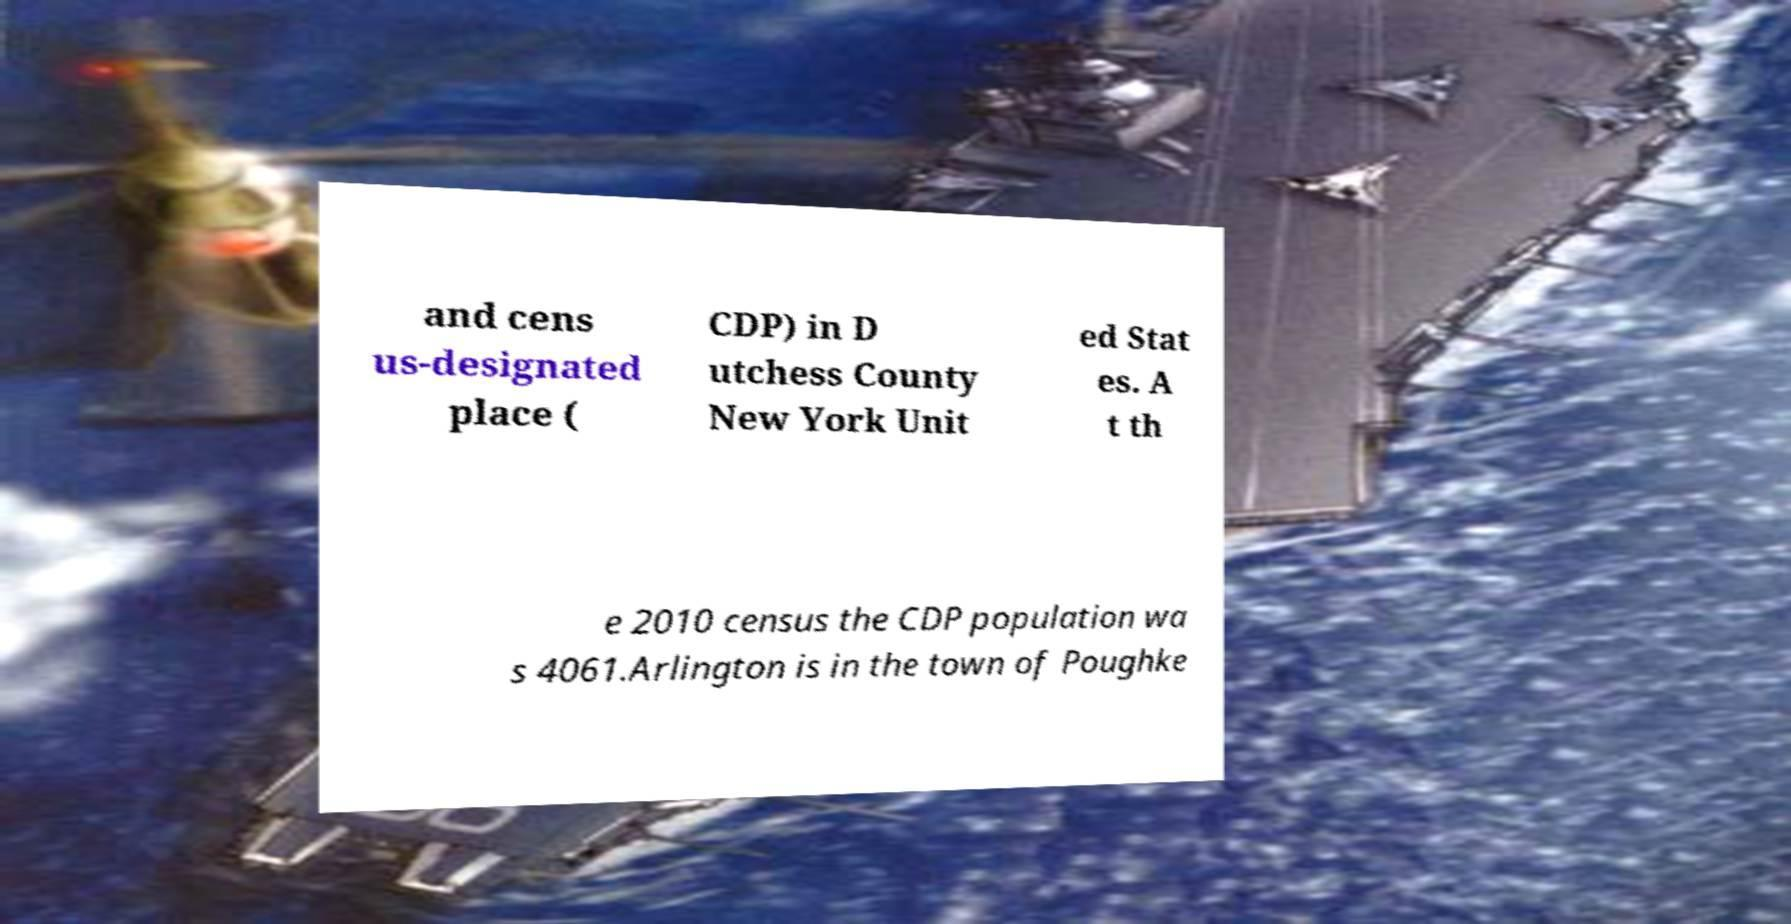There's text embedded in this image that I need extracted. Can you transcribe it verbatim? and cens us-designated place ( CDP) in D utchess County New York Unit ed Stat es. A t th e 2010 census the CDP population wa s 4061.Arlington is in the town of Poughke 